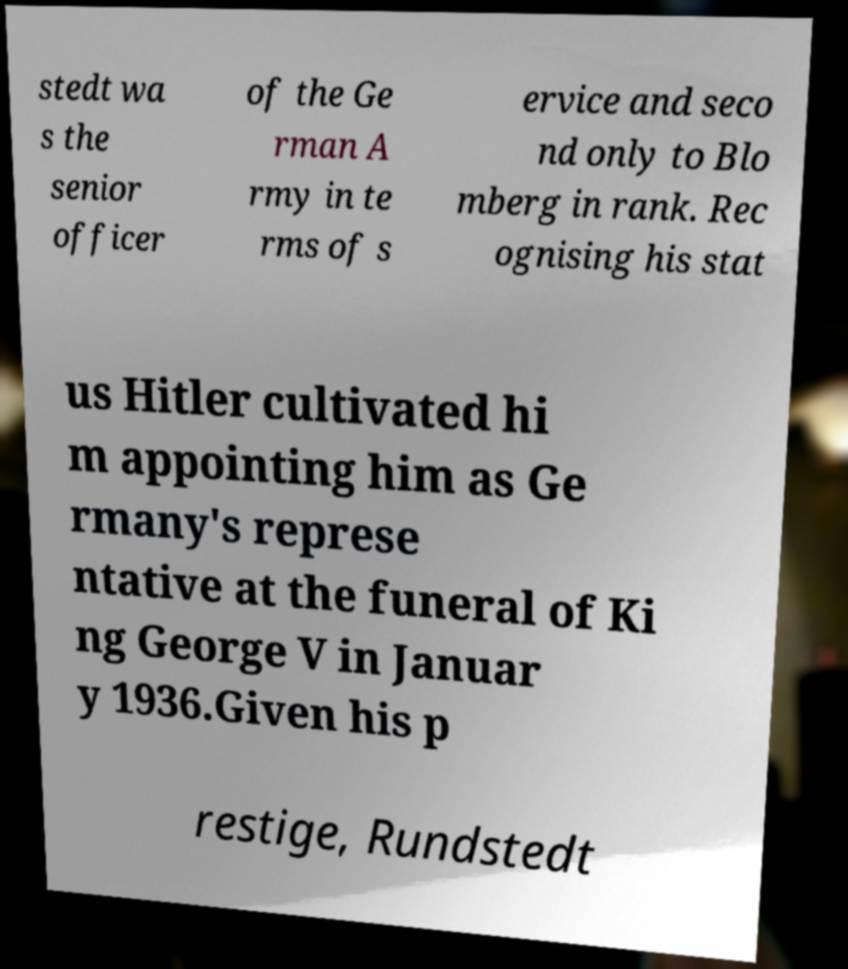Please identify and transcribe the text found in this image. stedt wa s the senior officer of the Ge rman A rmy in te rms of s ervice and seco nd only to Blo mberg in rank. Rec ognising his stat us Hitler cultivated hi m appointing him as Ge rmany's represe ntative at the funeral of Ki ng George V in Januar y 1936.Given his p restige, Rundstedt 